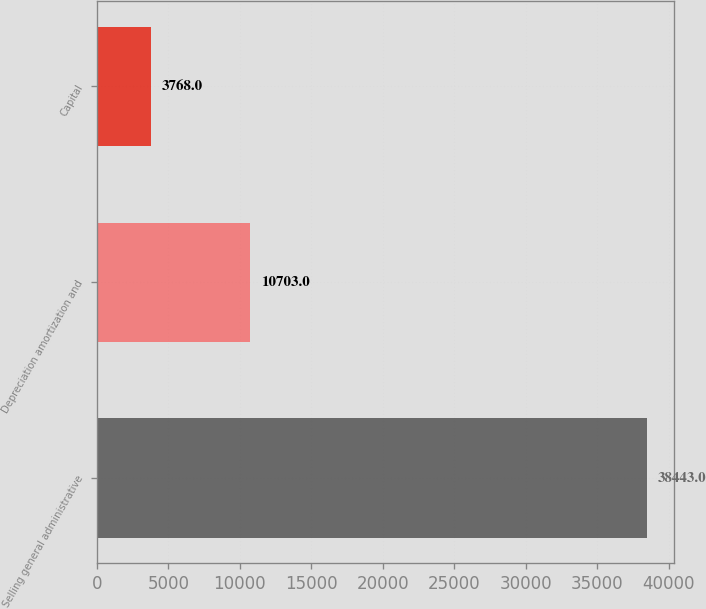Convert chart to OTSL. <chart><loc_0><loc_0><loc_500><loc_500><bar_chart><fcel>Selling general administrative<fcel>Depreciation amortization and<fcel>Capital<nl><fcel>38443<fcel>10703<fcel>3768<nl></chart> 